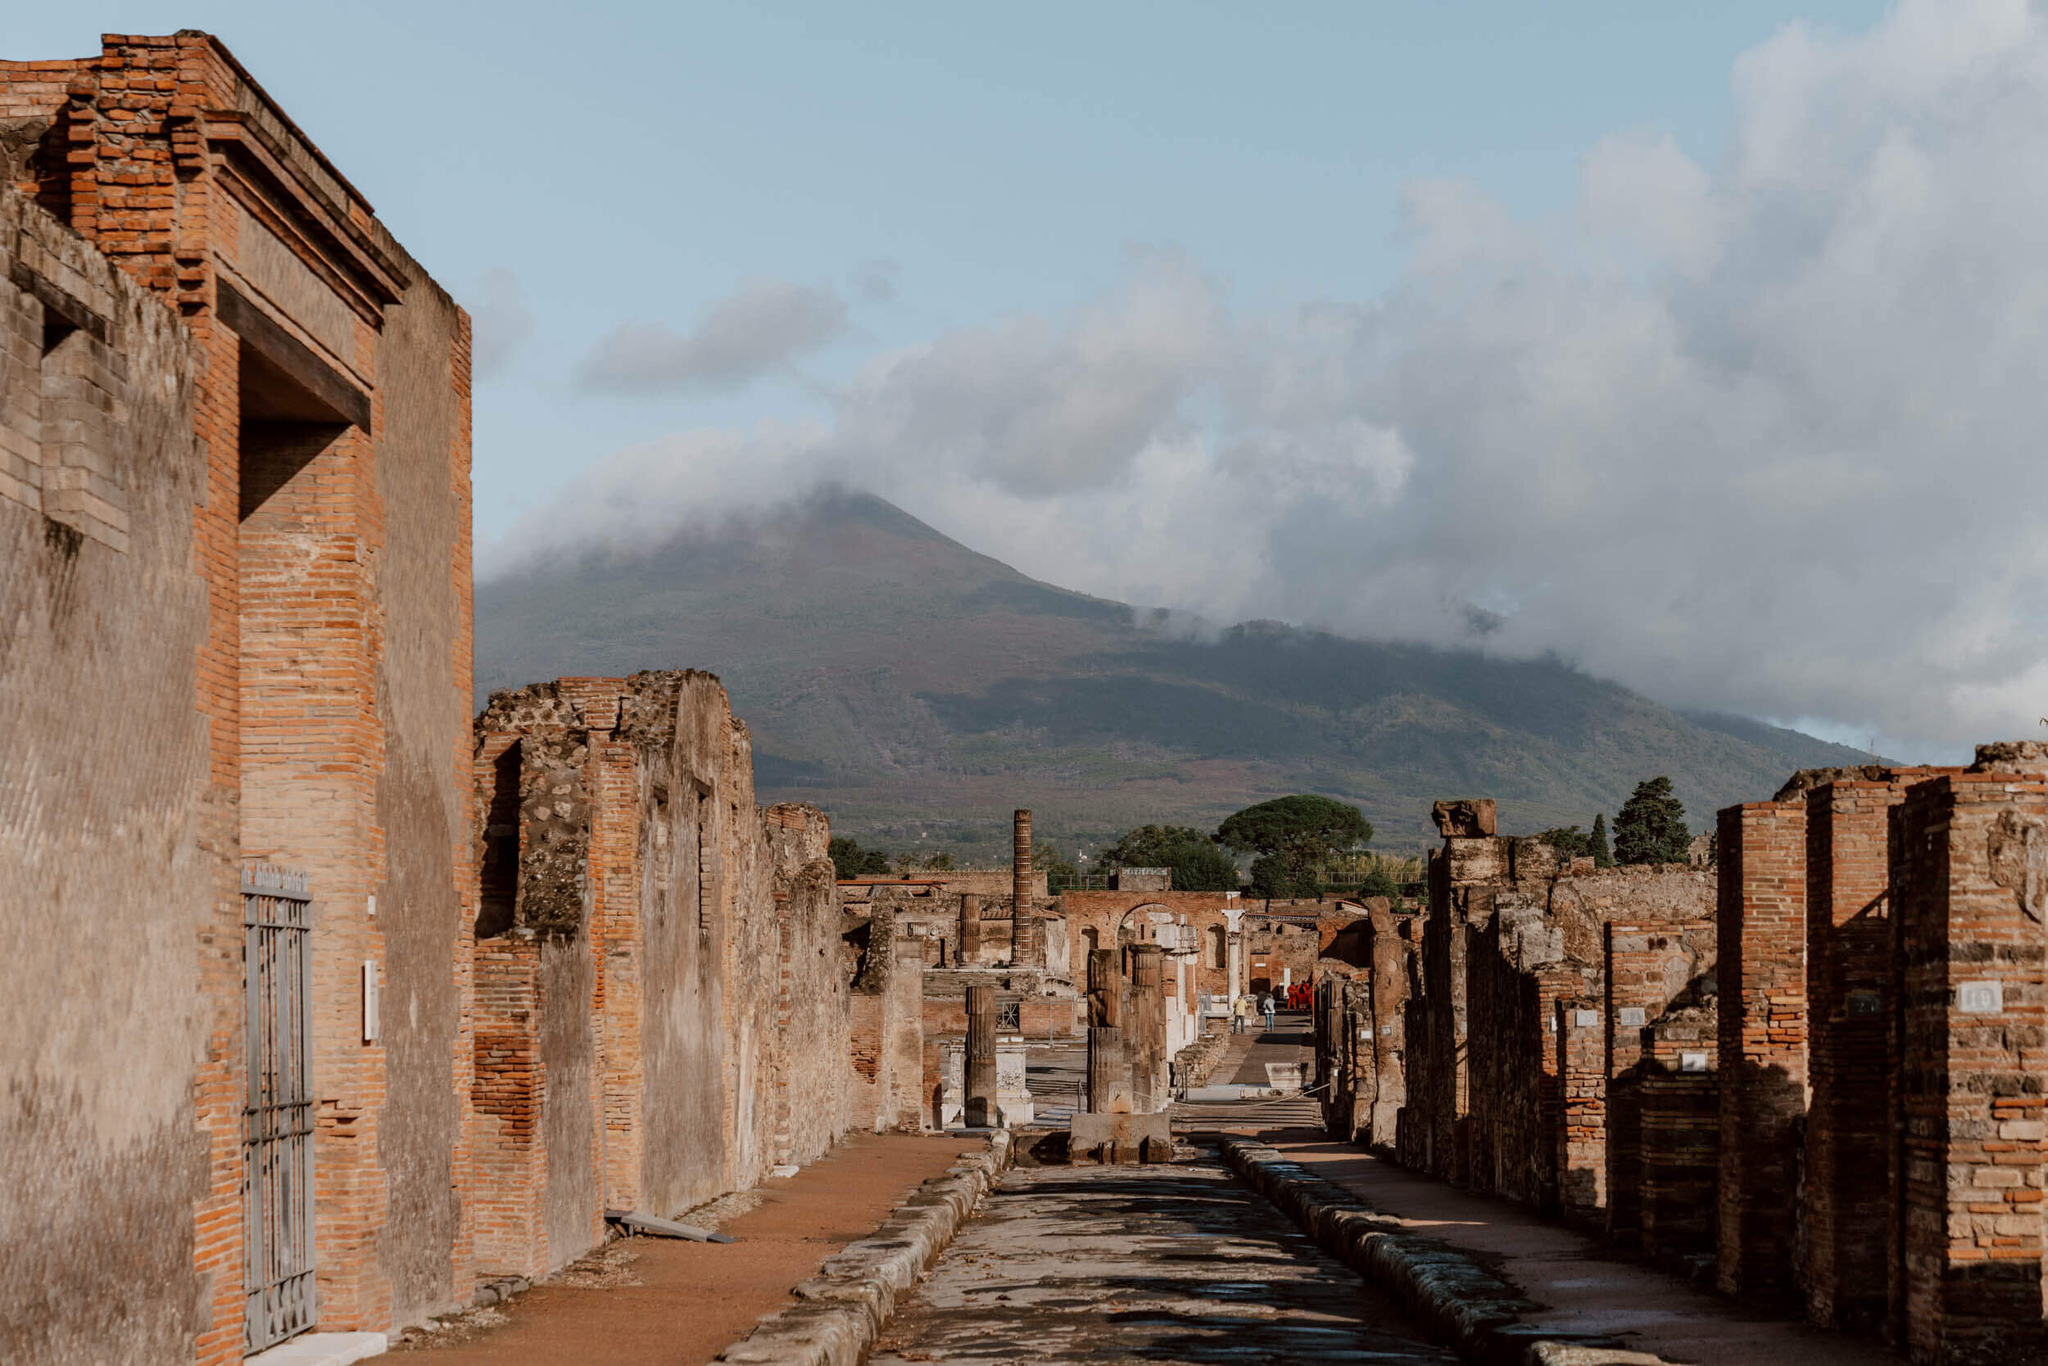Imagine the city of Pompeii if the eruption had never occurred. Describe the advancements or changes that might have taken place over the centuries. Had the catastrophic eruption of 79 AD never occurred, Pompeii would likely have continued to develop into a thriving urban center, reflecting the advancements and cultural shifts of successive eras. Over the centuries, the city might have seen the following changes and advancements:

1. **Architectural Evolution**: The buildings of Pompeii would have evolved, incorporating architectural styles and techniques from subsequent Roman periods, eventually amalgamating influences from the Byzantine, Medieval, and Renaissance periods. Grand basilicas, ornate palaces, and later, Baroque and neoclassical structures could have defined its skyline.

2. **Technological Progress**: As technology advanced, Pompeii’s infrastructure would have improved significantly. The already advanced waterworks system could have grown into more sophisticated plumbing and sewerage systems. Electricity and modern transportation networks, such as trams or trains, might have been integrated into the city's layout.

3. **Cultural Synthesis**: With a continuous influx of people, goods, and ideas, Pompeii would have been a melting pot of cultures. Public art, literature, and philosophy would reflect a confluence of Roman traditions with new influences, possibly leading to a unique regional culture.

4. **Economic Growth**: Positioned strategically near trade routes, Pompeii would have likely flourished as a significant trade hub. Expanding markets, trade fairs, and a bustling port might have attracted merchants and artisans from across the Mediterranean, contributing to economic prosperity.

5. **Urban Expansion**: The city could have expanded beyond its original confines, with new districts developing around the historic core. Suburbs might have formed, offering more spacious and modern housing options for an increasing population.

6. **Political Influence**: As a continually inhabited city, Pompeii might have played a role in regional politics, possibly becoming an administrative center. Its historical significance and growing population would contribute to its political importance.

Imagining a Pompeii untouched by volcanic destruction opens a window into a city that retained its ancient roots while embracing the transformations brought by time and progress, blending historical legacy with modern advancements. Casual Reflection: Standing in Pompeii today, what might have been a common sight along this street during its peak? During the peak of Pompeii, walking down this street, you would have encountered a lively and bustling scene. Merchants would be selling fresh produce, spices, and exotic items from various stalls. Citizens of all classes would be engaging in daily activities, some heading toward the public baths, others to the temples for worship. Children might be seen playing around, while craftsmen showcased their goods in front of their shops. Sounds of conversation, haggling, and laughter would fill the air. The street would be adorned with colorful awnings and murals, adding to the vibrant atmosphere. It was a city full of life, movement, and interaction, reflecting the richness of Roman urban culture. 